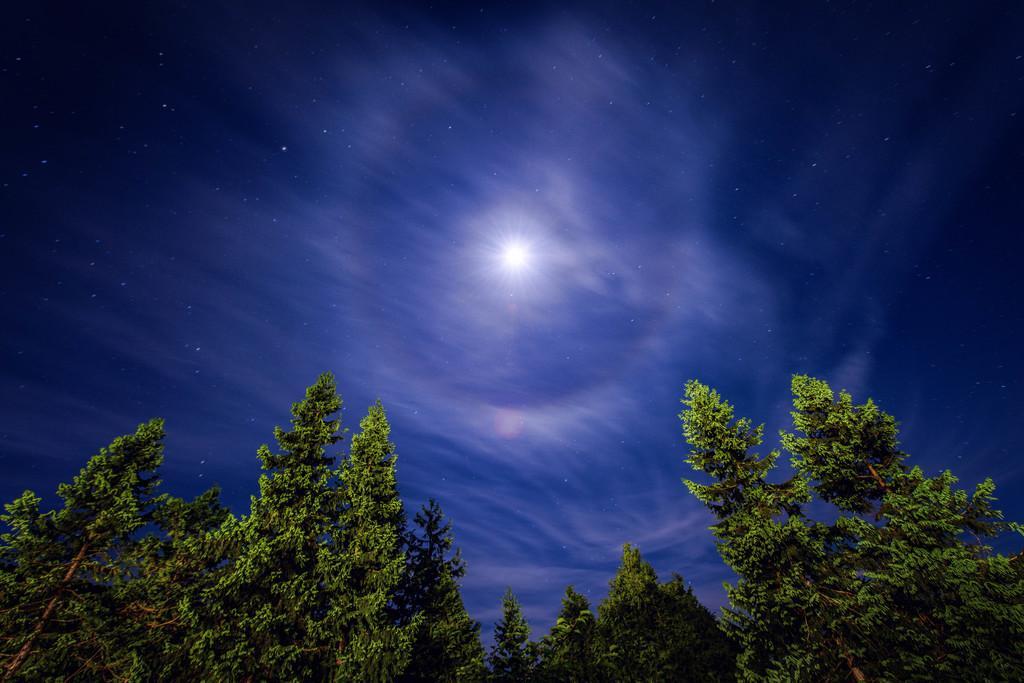How would you summarize this image in a sentence or two? In this picture we can see a few trees from left to right. There is a light in the sky. 